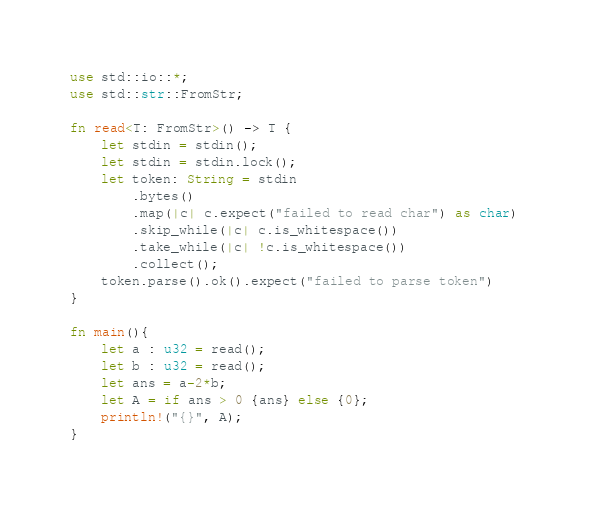<code> <loc_0><loc_0><loc_500><loc_500><_Rust_>use std::io::*;
use std::str::FromStr;

fn read<T: FromStr>() -> T {
    let stdin = stdin();
    let stdin = stdin.lock();
    let token: String = stdin
        .bytes()
        .map(|c| c.expect("failed to read char") as char) 
        .skip_while(|c| c.is_whitespace())
        .take_while(|c| !c.is_whitespace())
        .collect();
    token.parse().ok().expect("failed to parse token")
}

fn main(){
    let a : u32 = read();
    let b : u32 = read();
    let ans = a-2*b;
    let A = if ans > 0 {ans} else {0};
    println!("{}", A);
}</code> 